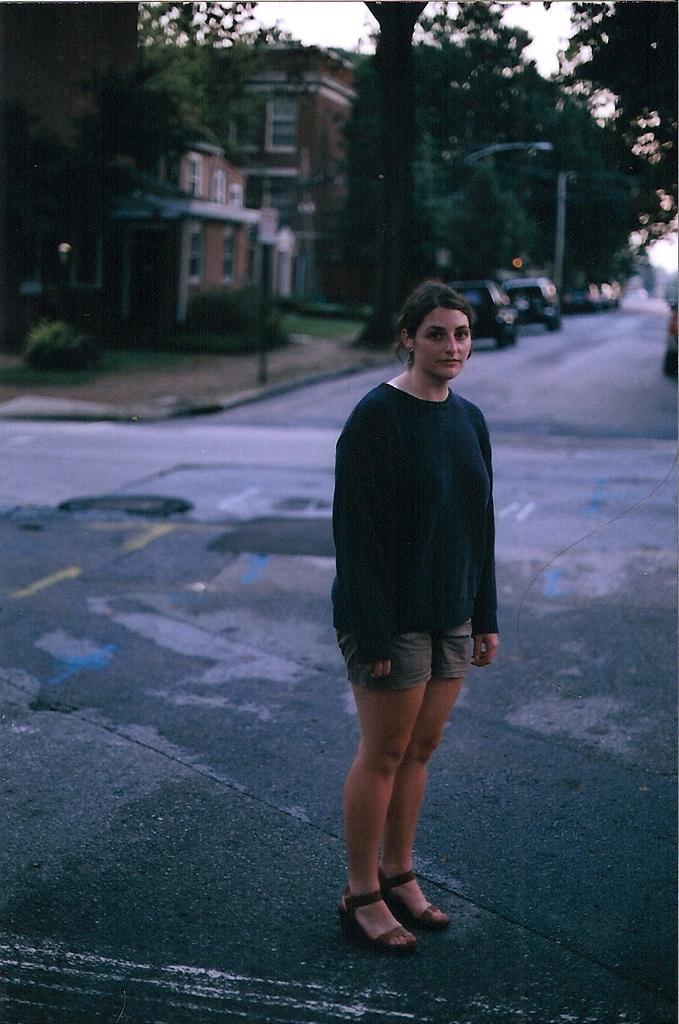Could you give a brief overview of what you see in this image? In this picture we can observe a woman standing on the road wearing black color T shirt. In the background we can observe two vehicles on the road. There are some trees and a building. We can observe a sky here. 